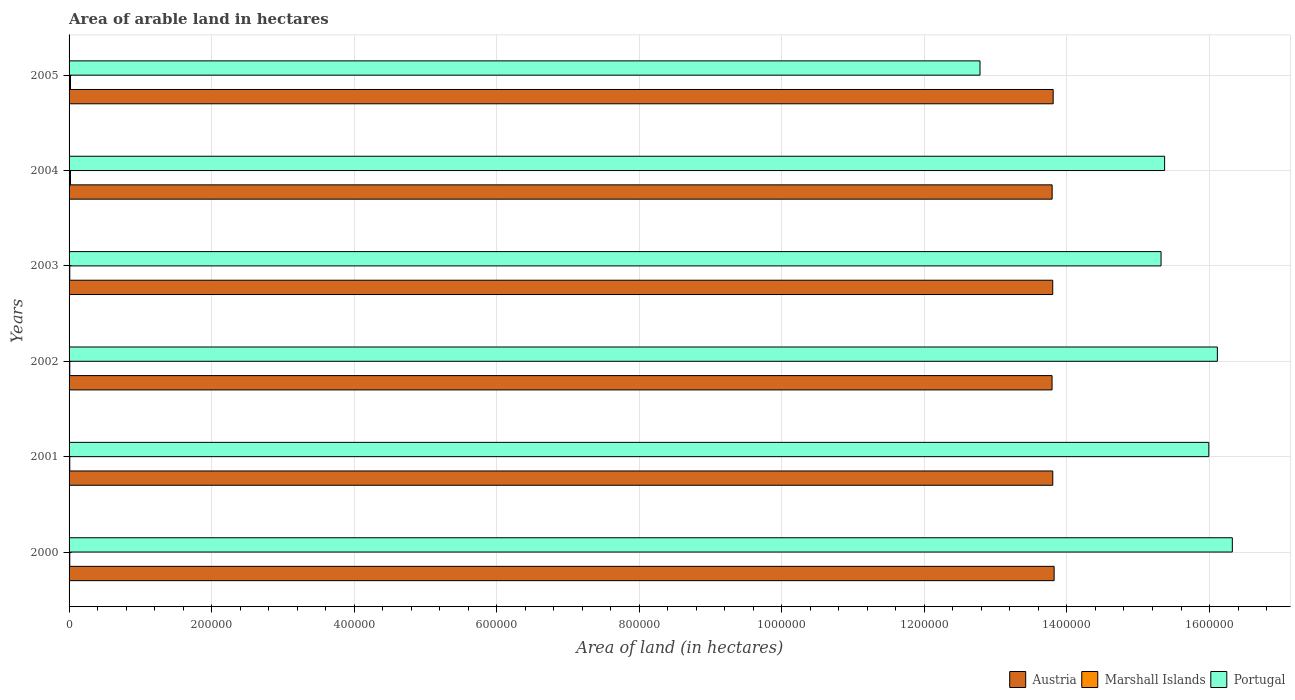How many groups of bars are there?
Give a very brief answer. 6. Are the number of bars on each tick of the Y-axis equal?
Your answer should be very brief. Yes. How many bars are there on the 6th tick from the top?
Give a very brief answer. 3. What is the total arable land in Austria in 2003?
Your response must be concise. 1.38e+06. Across all years, what is the maximum total arable land in Marshall Islands?
Provide a succinct answer. 2000. Across all years, what is the minimum total arable land in Austria?
Provide a short and direct response. 1.38e+06. In which year was the total arable land in Portugal maximum?
Provide a short and direct response. 2000. What is the total total arable land in Marshall Islands in the graph?
Provide a succinct answer. 8000. What is the difference between the total arable land in Austria in 2003 and that in 2005?
Your answer should be very brief. -620. What is the difference between the total arable land in Austria in 2005 and the total arable land in Portugal in 2003?
Offer a very short reply. -1.51e+05. What is the average total arable land in Marshall Islands per year?
Your response must be concise. 1333.33. In the year 2001, what is the difference between the total arable land in Portugal and total arable land in Austria?
Provide a short and direct response. 2.19e+05. In how many years, is the total arable land in Portugal greater than 120000 hectares?
Make the answer very short. 6. What is the ratio of the total arable land in Austria in 2002 to that in 2003?
Provide a short and direct response. 1. Is the total arable land in Marshall Islands in 2001 less than that in 2005?
Your answer should be compact. Yes. What is the difference between the highest and the second highest total arable land in Austria?
Your answer should be very brief. 1350. What is the difference between the highest and the lowest total arable land in Austria?
Your answer should be very brief. 2900. What does the 1st bar from the bottom in 2002 represents?
Your response must be concise. Austria. Is it the case that in every year, the sum of the total arable land in Portugal and total arable land in Marshall Islands is greater than the total arable land in Austria?
Your response must be concise. No. How many bars are there?
Make the answer very short. 18. Are all the bars in the graph horizontal?
Your response must be concise. Yes. Does the graph contain grids?
Offer a terse response. Yes. Where does the legend appear in the graph?
Provide a succinct answer. Bottom right. How many legend labels are there?
Give a very brief answer. 3. How are the legend labels stacked?
Ensure brevity in your answer.  Horizontal. What is the title of the graph?
Your answer should be compact. Area of arable land in hectares. Does "Portugal" appear as one of the legend labels in the graph?
Offer a very short reply. Yes. What is the label or title of the X-axis?
Offer a very short reply. Area of land (in hectares). What is the label or title of the Y-axis?
Ensure brevity in your answer.  Years. What is the Area of land (in hectares) of Austria in 2000?
Offer a very short reply. 1.38e+06. What is the Area of land (in hectares) in Marshall Islands in 2000?
Offer a very short reply. 1000. What is the Area of land (in hectares) in Portugal in 2000?
Give a very brief answer. 1.63e+06. What is the Area of land (in hectares) in Austria in 2001?
Your answer should be compact. 1.38e+06. What is the Area of land (in hectares) of Marshall Islands in 2001?
Give a very brief answer. 1000. What is the Area of land (in hectares) of Portugal in 2001?
Keep it short and to the point. 1.60e+06. What is the Area of land (in hectares) in Austria in 2002?
Make the answer very short. 1.38e+06. What is the Area of land (in hectares) in Portugal in 2002?
Make the answer very short. 1.61e+06. What is the Area of land (in hectares) in Austria in 2003?
Your response must be concise. 1.38e+06. What is the Area of land (in hectares) of Marshall Islands in 2003?
Give a very brief answer. 1000. What is the Area of land (in hectares) in Portugal in 2003?
Ensure brevity in your answer.  1.53e+06. What is the Area of land (in hectares) in Austria in 2004?
Ensure brevity in your answer.  1.38e+06. What is the Area of land (in hectares) in Portugal in 2004?
Your response must be concise. 1.54e+06. What is the Area of land (in hectares) in Austria in 2005?
Offer a very short reply. 1.38e+06. What is the Area of land (in hectares) in Portugal in 2005?
Provide a short and direct response. 1.28e+06. Across all years, what is the maximum Area of land (in hectares) in Austria?
Offer a terse response. 1.38e+06. Across all years, what is the maximum Area of land (in hectares) of Marshall Islands?
Make the answer very short. 2000. Across all years, what is the maximum Area of land (in hectares) of Portugal?
Provide a succinct answer. 1.63e+06. Across all years, what is the minimum Area of land (in hectares) of Austria?
Make the answer very short. 1.38e+06. Across all years, what is the minimum Area of land (in hectares) in Marshall Islands?
Your answer should be very brief. 1000. Across all years, what is the minimum Area of land (in hectares) of Portugal?
Make the answer very short. 1.28e+06. What is the total Area of land (in hectares) of Austria in the graph?
Provide a short and direct response. 8.28e+06. What is the total Area of land (in hectares) of Marshall Islands in the graph?
Give a very brief answer. 8000. What is the total Area of land (in hectares) of Portugal in the graph?
Provide a succinct answer. 9.19e+06. What is the difference between the Area of land (in hectares) in Austria in 2000 and that in 2001?
Keep it short and to the point. 1900. What is the difference between the Area of land (in hectares) of Marshall Islands in 2000 and that in 2001?
Your answer should be compact. 0. What is the difference between the Area of land (in hectares) of Portugal in 2000 and that in 2001?
Give a very brief answer. 3.30e+04. What is the difference between the Area of land (in hectares) in Austria in 2000 and that in 2002?
Your response must be concise. 2900. What is the difference between the Area of land (in hectares) of Portugal in 2000 and that in 2002?
Offer a very short reply. 2.10e+04. What is the difference between the Area of land (in hectares) in Austria in 2000 and that in 2003?
Provide a short and direct response. 1970. What is the difference between the Area of land (in hectares) in Marshall Islands in 2000 and that in 2003?
Your answer should be very brief. 0. What is the difference between the Area of land (in hectares) of Austria in 2000 and that in 2004?
Give a very brief answer. 2800. What is the difference between the Area of land (in hectares) in Marshall Islands in 2000 and that in 2004?
Make the answer very short. -1000. What is the difference between the Area of land (in hectares) in Portugal in 2000 and that in 2004?
Make the answer very short. 9.50e+04. What is the difference between the Area of land (in hectares) of Austria in 2000 and that in 2005?
Give a very brief answer. 1350. What is the difference between the Area of land (in hectares) of Marshall Islands in 2000 and that in 2005?
Make the answer very short. -1000. What is the difference between the Area of land (in hectares) in Portugal in 2000 and that in 2005?
Make the answer very short. 3.54e+05. What is the difference between the Area of land (in hectares) in Marshall Islands in 2001 and that in 2002?
Ensure brevity in your answer.  0. What is the difference between the Area of land (in hectares) in Portugal in 2001 and that in 2002?
Your answer should be very brief. -1.20e+04. What is the difference between the Area of land (in hectares) in Austria in 2001 and that in 2003?
Your answer should be very brief. 70. What is the difference between the Area of land (in hectares) of Portugal in 2001 and that in 2003?
Provide a succinct answer. 6.70e+04. What is the difference between the Area of land (in hectares) in Austria in 2001 and that in 2004?
Make the answer very short. 900. What is the difference between the Area of land (in hectares) of Marshall Islands in 2001 and that in 2004?
Ensure brevity in your answer.  -1000. What is the difference between the Area of land (in hectares) in Portugal in 2001 and that in 2004?
Offer a very short reply. 6.20e+04. What is the difference between the Area of land (in hectares) of Austria in 2001 and that in 2005?
Give a very brief answer. -550. What is the difference between the Area of land (in hectares) in Marshall Islands in 2001 and that in 2005?
Provide a short and direct response. -1000. What is the difference between the Area of land (in hectares) of Portugal in 2001 and that in 2005?
Make the answer very short. 3.21e+05. What is the difference between the Area of land (in hectares) in Austria in 2002 and that in 2003?
Offer a terse response. -930. What is the difference between the Area of land (in hectares) of Portugal in 2002 and that in 2003?
Make the answer very short. 7.90e+04. What is the difference between the Area of land (in hectares) in Austria in 2002 and that in 2004?
Keep it short and to the point. -100. What is the difference between the Area of land (in hectares) in Marshall Islands in 2002 and that in 2004?
Give a very brief answer. -1000. What is the difference between the Area of land (in hectares) of Portugal in 2002 and that in 2004?
Your answer should be very brief. 7.40e+04. What is the difference between the Area of land (in hectares) of Austria in 2002 and that in 2005?
Your answer should be compact. -1550. What is the difference between the Area of land (in hectares) in Marshall Islands in 2002 and that in 2005?
Provide a succinct answer. -1000. What is the difference between the Area of land (in hectares) of Portugal in 2002 and that in 2005?
Ensure brevity in your answer.  3.33e+05. What is the difference between the Area of land (in hectares) of Austria in 2003 and that in 2004?
Your answer should be compact. 830. What is the difference between the Area of land (in hectares) of Marshall Islands in 2003 and that in 2004?
Your answer should be very brief. -1000. What is the difference between the Area of land (in hectares) in Portugal in 2003 and that in 2004?
Offer a terse response. -5000. What is the difference between the Area of land (in hectares) of Austria in 2003 and that in 2005?
Provide a short and direct response. -620. What is the difference between the Area of land (in hectares) of Marshall Islands in 2003 and that in 2005?
Give a very brief answer. -1000. What is the difference between the Area of land (in hectares) in Portugal in 2003 and that in 2005?
Offer a terse response. 2.54e+05. What is the difference between the Area of land (in hectares) in Austria in 2004 and that in 2005?
Make the answer very short. -1450. What is the difference between the Area of land (in hectares) in Marshall Islands in 2004 and that in 2005?
Your answer should be compact. 0. What is the difference between the Area of land (in hectares) in Portugal in 2004 and that in 2005?
Ensure brevity in your answer.  2.59e+05. What is the difference between the Area of land (in hectares) in Austria in 2000 and the Area of land (in hectares) in Marshall Islands in 2001?
Your answer should be very brief. 1.38e+06. What is the difference between the Area of land (in hectares) of Austria in 2000 and the Area of land (in hectares) of Portugal in 2001?
Your answer should be compact. -2.17e+05. What is the difference between the Area of land (in hectares) of Marshall Islands in 2000 and the Area of land (in hectares) of Portugal in 2001?
Offer a terse response. -1.60e+06. What is the difference between the Area of land (in hectares) in Austria in 2000 and the Area of land (in hectares) in Marshall Islands in 2002?
Keep it short and to the point. 1.38e+06. What is the difference between the Area of land (in hectares) in Austria in 2000 and the Area of land (in hectares) in Portugal in 2002?
Your answer should be compact. -2.29e+05. What is the difference between the Area of land (in hectares) in Marshall Islands in 2000 and the Area of land (in hectares) in Portugal in 2002?
Your answer should be very brief. -1.61e+06. What is the difference between the Area of land (in hectares) in Austria in 2000 and the Area of land (in hectares) in Marshall Islands in 2003?
Keep it short and to the point. 1.38e+06. What is the difference between the Area of land (in hectares) of Marshall Islands in 2000 and the Area of land (in hectares) of Portugal in 2003?
Your answer should be very brief. -1.53e+06. What is the difference between the Area of land (in hectares) of Austria in 2000 and the Area of land (in hectares) of Marshall Islands in 2004?
Your answer should be very brief. 1.38e+06. What is the difference between the Area of land (in hectares) in Austria in 2000 and the Area of land (in hectares) in Portugal in 2004?
Give a very brief answer. -1.55e+05. What is the difference between the Area of land (in hectares) in Marshall Islands in 2000 and the Area of land (in hectares) in Portugal in 2004?
Your answer should be compact. -1.54e+06. What is the difference between the Area of land (in hectares) of Austria in 2000 and the Area of land (in hectares) of Marshall Islands in 2005?
Make the answer very short. 1.38e+06. What is the difference between the Area of land (in hectares) in Austria in 2000 and the Area of land (in hectares) in Portugal in 2005?
Offer a terse response. 1.04e+05. What is the difference between the Area of land (in hectares) of Marshall Islands in 2000 and the Area of land (in hectares) of Portugal in 2005?
Offer a very short reply. -1.28e+06. What is the difference between the Area of land (in hectares) of Austria in 2001 and the Area of land (in hectares) of Marshall Islands in 2002?
Offer a terse response. 1.38e+06. What is the difference between the Area of land (in hectares) in Austria in 2001 and the Area of land (in hectares) in Portugal in 2002?
Offer a terse response. -2.31e+05. What is the difference between the Area of land (in hectares) in Marshall Islands in 2001 and the Area of land (in hectares) in Portugal in 2002?
Offer a very short reply. -1.61e+06. What is the difference between the Area of land (in hectares) in Austria in 2001 and the Area of land (in hectares) in Marshall Islands in 2003?
Your response must be concise. 1.38e+06. What is the difference between the Area of land (in hectares) of Austria in 2001 and the Area of land (in hectares) of Portugal in 2003?
Your answer should be compact. -1.52e+05. What is the difference between the Area of land (in hectares) in Marshall Islands in 2001 and the Area of land (in hectares) in Portugal in 2003?
Provide a short and direct response. -1.53e+06. What is the difference between the Area of land (in hectares) of Austria in 2001 and the Area of land (in hectares) of Marshall Islands in 2004?
Your response must be concise. 1.38e+06. What is the difference between the Area of land (in hectares) of Austria in 2001 and the Area of land (in hectares) of Portugal in 2004?
Keep it short and to the point. -1.57e+05. What is the difference between the Area of land (in hectares) in Marshall Islands in 2001 and the Area of land (in hectares) in Portugal in 2004?
Give a very brief answer. -1.54e+06. What is the difference between the Area of land (in hectares) of Austria in 2001 and the Area of land (in hectares) of Marshall Islands in 2005?
Provide a short and direct response. 1.38e+06. What is the difference between the Area of land (in hectares) of Austria in 2001 and the Area of land (in hectares) of Portugal in 2005?
Your response must be concise. 1.02e+05. What is the difference between the Area of land (in hectares) in Marshall Islands in 2001 and the Area of land (in hectares) in Portugal in 2005?
Keep it short and to the point. -1.28e+06. What is the difference between the Area of land (in hectares) of Austria in 2002 and the Area of land (in hectares) of Marshall Islands in 2003?
Your answer should be very brief. 1.38e+06. What is the difference between the Area of land (in hectares) in Austria in 2002 and the Area of land (in hectares) in Portugal in 2003?
Make the answer very short. -1.53e+05. What is the difference between the Area of land (in hectares) in Marshall Islands in 2002 and the Area of land (in hectares) in Portugal in 2003?
Your response must be concise. -1.53e+06. What is the difference between the Area of land (in hectares) in Austria in 2002 and the Area of land (in hectares) in Marshall Islands in 2004?
Provide a succinct answer. 1.38e+06. What is the difference between the Area of land (in hectares) in Austria in 2002 and the Area of land (in hectares) in Portugal in 2004?
Provide a short and direct response. -1.58e+05. What is the difference between the Area of land (in hectares) of Marshall Islands in 2002 and the Area of land (in hectares) of Portugal in 2004?
Ensure brevity in your answer.  -1.54e+06. What is the difference between the Area of land (in hectares) of Austria in 2002 and the Area of land (in hectares) of Marshall Islands in 2005?
Your response must be concise. 1.38e+06. What is the difference between the Area of land (in hectares) of Austria in 2002 and the Area of land (in hectares) of Portugal in 2005?
Your answer should be compact. 1.01e+05. What is the difference between the Area of land (in hectares) in Marshall Islands in 2002 and the Area of land (in hectares) in Portugal in 2005?
Offer a terse response. -1.28e+06. What is the difference between the Area of land (in hectares) in Austria in 2003 and the Area of land (in hectares) in Marshall Islands in 2004?
Keep it short and to the point. 1.38e+06. What is the difference between the Area of land (in hectares) in Austria in 2003 and the Area of land (in hectares) in Portugal in 2004?
Your response must be concise. -1.57e+05. What is the difference between the Area of land (in hectares) in Marshall Islands in 2003 and the Area of land (in hectares) in Portugal in 2004?
Your answer should be compact. -1.54e+06. What is the difference between the Area of land (in hectares) in Austria in 2003 and the Area of land (in hectares) in Marshall Islands in 2005?
Your response must be concise. 1.38e+06. What is the difference between the Area of land (in hectares) of Austria in 2003 and the Area of land (in hectares) of Portugal in 2005?
Give a very brief answer. 1.02e+05. What is the difference between the Area of land (in hectares) in Marshall Islands in 2003 and the Area of land (in hectares) in Portugal in 2005?
Give a very brief answer. -1.28e+06. What is the difference between the Area of land (in hectares) in Austria in 2004 and the Area of land (in hectares) in Marshall Islands in 2005?
Offer a terse response. 1.38e+06. What is the difference between the Area of land (in hectares) of Austria in 2004 and the Area of land (in hectares) of Portugal in 2005?
Offer a very short reply. 1.01e+05. What is the difference between the Area of land (in hectares) of Marshall Islands in 2004 and the Area of land (in hectares) of Portugal in 2005?
Provide a short and direct response. -1.28e+06. What is the average Area of land (in hectares) of Austria per year?
Keep it short and to the point. 1.38e+06. What is the average Area of land (in hectares) in Marshall Islands per year?
Make the answer very short. 1333.33. What is the average Area of land (in hectares) of Portugal per year?
Give a very brief answer. 1.53e+06. In the year 2000, what is the difference between the Area of land (in hectares) in Austria and Area of land (in hectares) in Marshall Islands?
Your answer should be compact. 1.38e+06. In the year 2000, what is the difference between the Area of land (in hectares) of Austria and Area of land (in hectares) of Portugal?
Ensure brevity in your answer.  -2.50e+05. In the year 2000, what is the difference between the Area of land (in hectares) in Marshall Islands and Area of land (in hectares) in Portugal?
Provide a succinct answer. -1.63e+06. In the year 2001, what is the difference between the Area of land (in hectares) of Austria and Area of land (in hectares) of Marshall Islands?
Provide a short and direct response. 1.38e+06. In the year 2001, what is the difference between the Area of land (in hectares) of Austria and Area of land (in hectares) of Portugal?
Offer a very short reply. -2.19e+05. In the year 2001, what is the difference between the Area of land (in hectares) of Marshall Islands and Area of land (in hectares) of Portugal?
Provide a succinct answer. -1.60e+06. In the year 2002, what is the difference between the Area of land (in hectares) of Austria and Area of land (in hectares) of Marshall Islands?
Make the answer very short. 1.38e+06. In the year 2002, what is the difference between the Area of land (in hectares) in Austria and Area of land (in hectares) in Portugal?
Offer a terse response. -2.32e+05. In the year 2002, what is the difference between the Area of land (in hectares) in Marshall Islands and Area of land (in hectares) in Portugal?
Provide a short and direct response. -1.61e+06. In the year 2003, what is the difference between the Area of land (in hectares) in Austria and Area of land (in hectares) in Marshall Islands?
Keep it short and to the point. 1.38e+06. In the year 2003, what is the difference between the Area of land (in hectares) in Austria and Area of land (in hectares) in Portugal?
Provide a short and direct response. -1.52e+05. In the year 2003, what is the difference between the Area of land (in hectares) of Marshall Islands and Area of land (in hectares) of Portugal?
Your answer should be very brief. -1.53e+06. In the year 2004, what is the difference between the Area of land (in hectares) in Austria and Area of land (in hectares) in Marshall Islands?
Make the answer very short. 1.38e+06. In the year 2004, what is the difference between the Area of land (in hectares) in Austria and Area of land (in hectares) in Portugal?
Provide a succinct answer. -1.58e+05. In the year 2004, what is the difference between the Area of land (in hectares) in Marshall Islands and Area of land (in hectares) in Portugal?
Offer a very short reply. -1.54e+06. In the year 2005, what is the difference between the Area of land (in hectares) of Austria and Area of land (in hectares) of Marshall Islands?
Provide a succinct answer. 1.38e+06. In the year 2005, what is the difference between the Area of land (in hectares) of Austria and Area of land (in hectares) of Portugal?
Make the answer very short. 1.03e+05. In the year 2005, what is the difference between the Area of land (in hectares) in Marshall Islands and Area of land (in hectares) in Portugal?
Your answer should be very brief. -1.28e+06. What is the ratio of the Area of land (in hectares) in Portugal in 2000 to that in 2001?
Your response must be concise. 1.02. What is the ratio of the Area of land (in hectares) of Marshall Islands in 2000 to that in 2002?
Make the answer very short. 1. What is the ratio of the Area of land (in hectares) in Portugal in 2000 to that in 2002?
Provide a succinct answer. 1.01. What is the ratio of the Area of land (in hectares) of Austria in 2000 to that in 2003?
Make the answer very short. 1. What is the ratio of the Area of land (in hectares) in Portugal in 2000 to that in 2003?
Your answer should be compact. 1.07. What is the ratio of the Area of land (in hectares) in Marshall Islands in 2000 to that in 2004?
Your answer should be compact. 0.5. What is the ratio of the Area of land (in hectares) in Portugal in 2000 to that in 2004?
Give a very brief answer. 1.06. What is the ratio of the Area of land (in hectares) in Austria in 2000 to that in 2005?
Ensure brevity in your answer.  1. What is the ratio of the Area of land (in hectares) in Marshall Islands in 2000 to that in 2005?
Offer a terse response. 0.5. What is the ratio of the Area of land (in hectares) in Portugal in 2000 to that in 2005?
Your answer should be compact. 1.28. What is the ratio of the Area of land (in hectares) of Austria in 2001 to that in 2002?
Your response must be concise. 1. What is the ratio of the Area of land (in hectares) in Marshall Islands in 2001 to that in 2002?
Make the answer very short. 1. What is the ratio of the Area of land (in hectares) of Austria in 2001 to that in 2003?
Your response must be concise. 1. What is the ratio of the Area of land (in hectares) in Marshall Islands in 2001 to that in 2003?
Your answer should be very brief. 1. What is the ratio of the Area of land (in hectares) of Portugal in 2001 to that in 2003?
Provide a succinct answer. 1.04. What is the ratio of the Area of land (in hectares) in Marshall Islands in 2001 to that in 2004?
Your response must be concise. 0.5. What is the ratio of the Area of land (in hectares) of Portugal in 2001 to that in 2004?
Provide a short and direct response. 1.04. What is the ratio of the Area of land (in hectares) in Austria in 2001 to that in 2005?
Your response must be concise. 1. What is the ratio of the Area of land (in hectares) of Marshall Islands in 2001 to that in 2005?
Your answer should be compact. 0.5. What is the ratio of the Area of land (in hectares) in Portugal in 2001 to that in 2005?
Keep it short and to the point. 1.25. What is the ratio of the Area of land (in hectares) in Austria in 2002 to that in 2003?
Ensure brevity in your answer.  1. What is the ratio of the Area of land (in hectares) in Portugal in 2002 to that in 2003?
Give a very brief answer. 1.05. What is the ratio of the Area of land (in hectares) in Marshall Islands in 2002 to that in 2004?
Keep it short and to the point. 0.5. What is the ratio of the Area of land (in hectares) of Portugal in 2002 to that in 2004?
Provide a short and direct response. 1.05. What is the ratio of the Area of land (in hectares) of Austria in 2002 to that in 2005?
Make the answer very short. 1. What is the ratio of the Area of land (in hectares) in Portugal in 2002 to that in 2005?
Keep it short and to the point. 1.26. What is the ratio of the Area of land (in hectares) of Austria in 2003 to that in 2004?
Give a very brief answer. 1. What is the ratio of the Area of land (in hectares) in Marshall Islands in 2003 to that in 2004?
Give a very brief answer. 0.5. What is the ratio of the Area of land (in hectares) in Portugal in 2003 to that in 2005?
Make the answer very short. 1.2. What is the ratio of the Area of land (in hectares) in Austria in 2004 to that in 2005?
Provide a short and direct response. 1. What is the ratio of the Area of land (in hectares) of Portugal in 2004 to that in 2005?
Your answer should be compact. 1.2. What is the difference between the highest and the second highest Area of land (in hectares) in Austria?
Your response must be concise. 1350. What is the difference between the highest and the second highest Area of land (in hectares) of Portugal?
Ensure brevity in your answer.  2.10e+04. What is the difference between the highest and the lowest Area of land (in hectares) in Austria?
Make the answer very short. 2900. What is the difference between the highest and the lowest Area of land (in hectares) in Portugal?
Keep it short and to the point. 3.54e+05. 